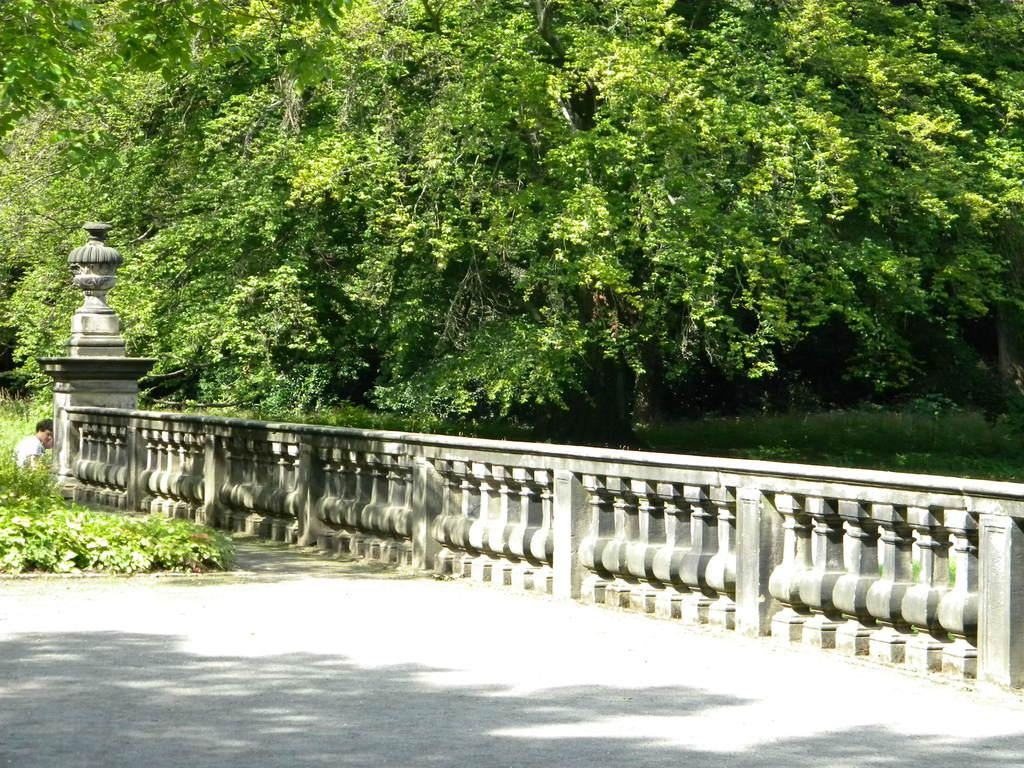What type of barrier can be seen in the image? There is a fence in the image. What other natural elements are present in the image? There are plants in the image. Can you describe the person in the image? There is a person in the image. What can be seen in the background of the image? There are trees in the background of the image. Where is the throne located in the image? There is no throne present in the image. What type of cable can be seen connecting the plants in the image? There is no cable connecting the plants in the image. 